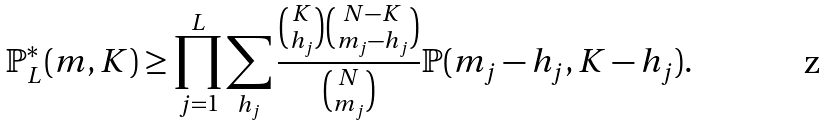<formula> <loc_0><loc_0><loc_500><loc_500>\mathbb { P } _ { L } ^ { * } ( m , K ) \geq \prod _ { j = 1 } ^ { L } \sum _ { h _ { j } } \frac { \binom { K } { h _ { j } } \binom { N - K } { m _ { j } - h _ { j } } } { \binom { N } { m _ { j } } } \mathbb { P } ( m _ { j } - h _ { j } , K - h _ { j } ) .</formula> 